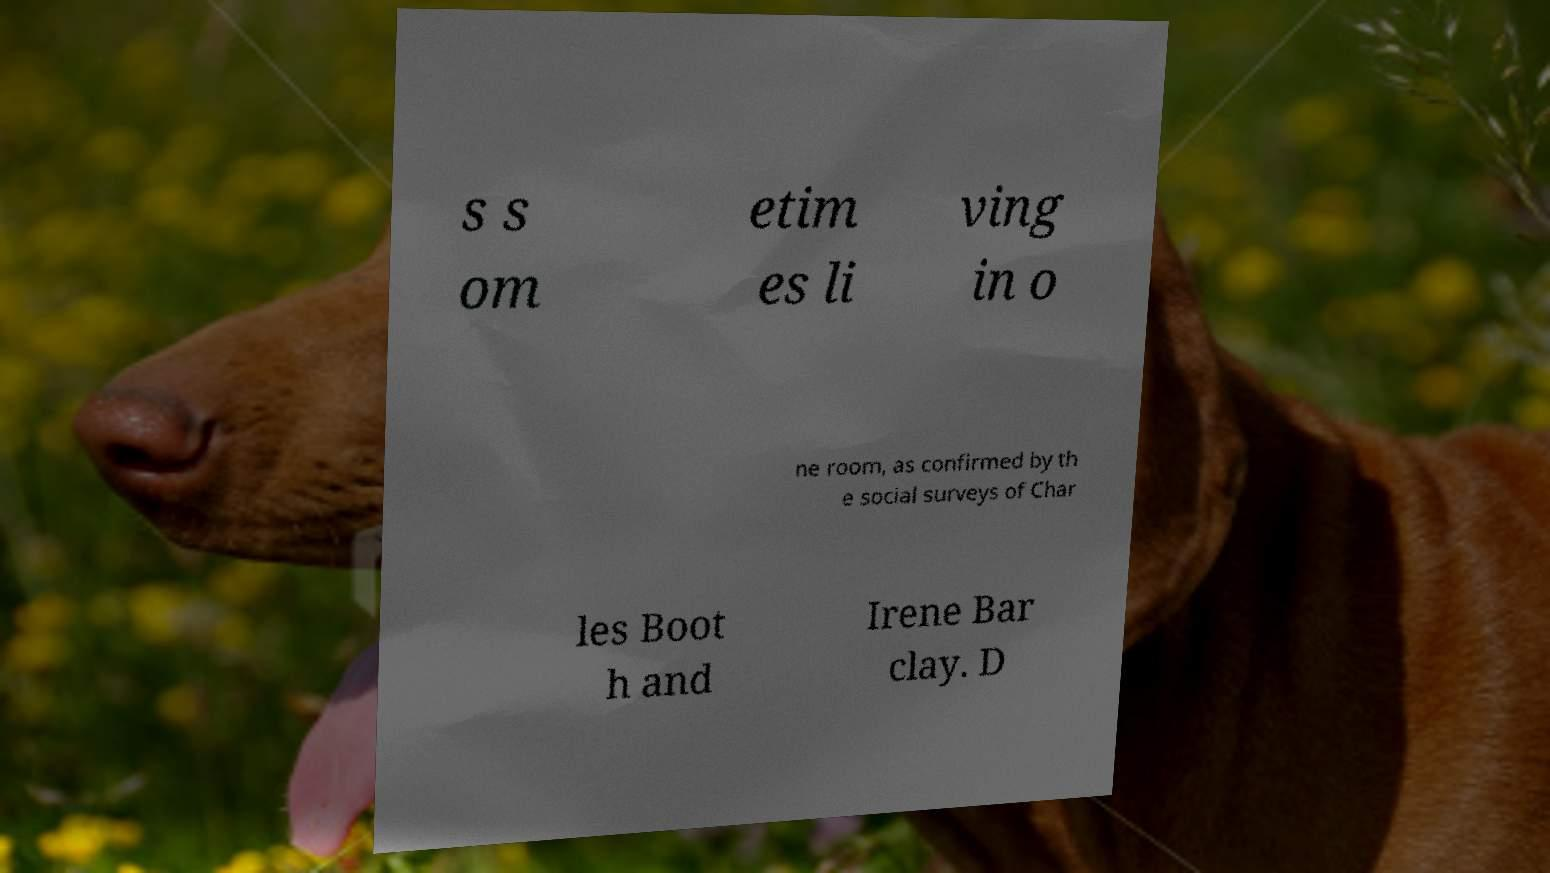I need the written content from this picture converted into text. Can you do that? s s om etim es li ving in o ne room, as confirmed by th e social surveys of Char les Boot h and Irene Bar clay. D 